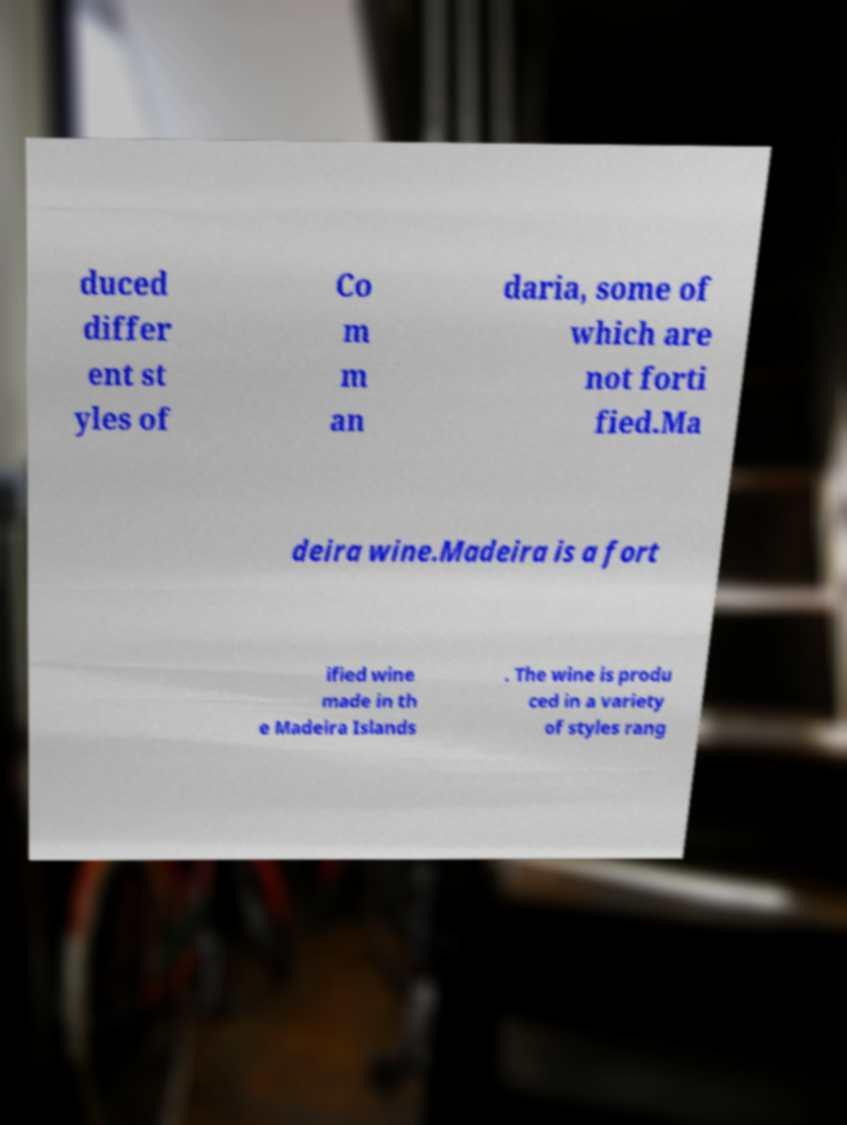Can you accurately transcribe the text from the provided image for me? duced differ ent st yles of Co m m an daria, some of which are not forti fied.Ma deira wine.Madeira is a fort ified wine made in th e Madeira Islands . The wine is produ ced in a variety of styles rang 